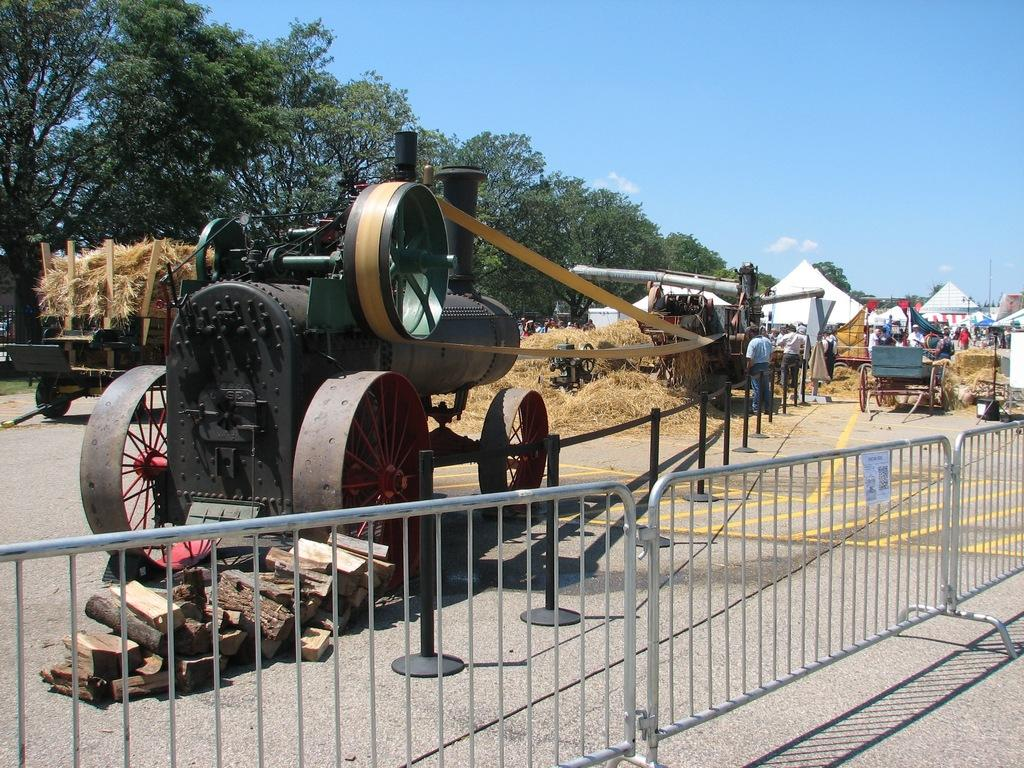What types of vehicles can be seen in the image? There are vehicles in the image, but the specific types are not mentioned. What is the ground cover in the image? Dry grass is present in the image. How many persons are visible in the image? There are persons in the image, but the exact number is not specified. What type of temporary shelter is visible in the image? Tents are visible in the image. What type of vegetation is present in the image? Trees are present in the image. What type of barrier is present in the image? There is a fence in the image. What other objects are on the ground in the image? Other objects are on the ground in the image, but their specific nature is not mentioned. What can be seen in the sky in the background of the image? There are clouds in the sky in the background of the image. What does your uncle say about the science behind the thing in the image? There is no mention of an uncle or any scientific discussion in the image. The image features vehicles, dry grass, persons, tents, trees, a fence, other objects, and clouds in the sky. 